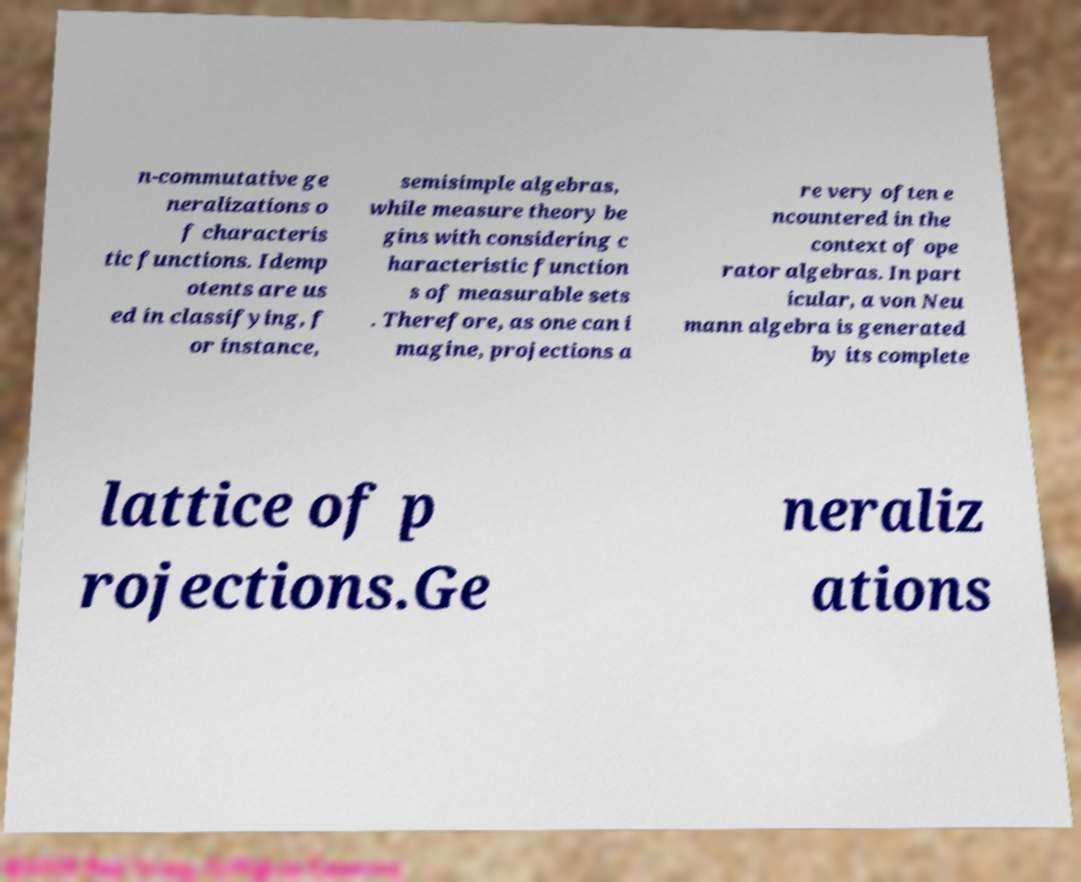There's text embedded in this image that I need extracted. Can you transcribe it verbatim? n-commutative ge neralizations o f characteris tic functions. Idemp otents are us ed in classifying, f or instance, semisimple algebras, while measure theory be gins with considering c haracteristic function s of measurable sets . Therefore, as one can i magine, projections a re very often e ncountered in the context of ope rator algebras. In part icular, a von Neu mann algebra is generated by its complete lattice of p rojections.Ge neraliz ations 